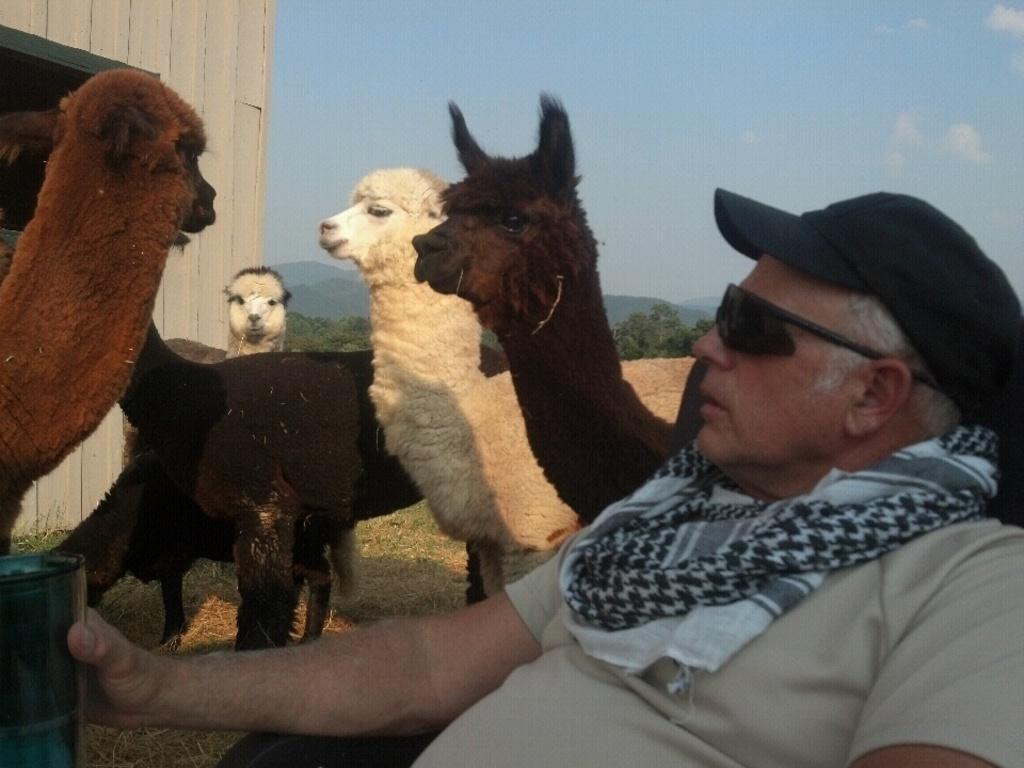In one or two sentences, can you explain what this image depicts? In this image, I can see the man sitting and holding an object in his hand. I can see a group of llama animals. On the left side of the image, It looks like a building wall. In the background, I can see the trees and hills. At the top of the image, I can see the sky. 